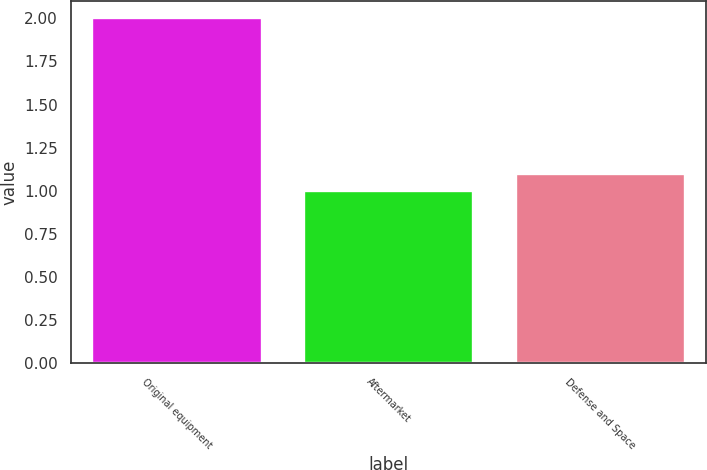Convert chart to OTSL. <chart><loc_0><loc_0><loc_500><loc_500><bar_chart><fcel>Original equipment<fcel>Aftermarket<fcel>Defense and Space<nl><fcel>2<fcel>1<fcel>1.1<nl></chart> 